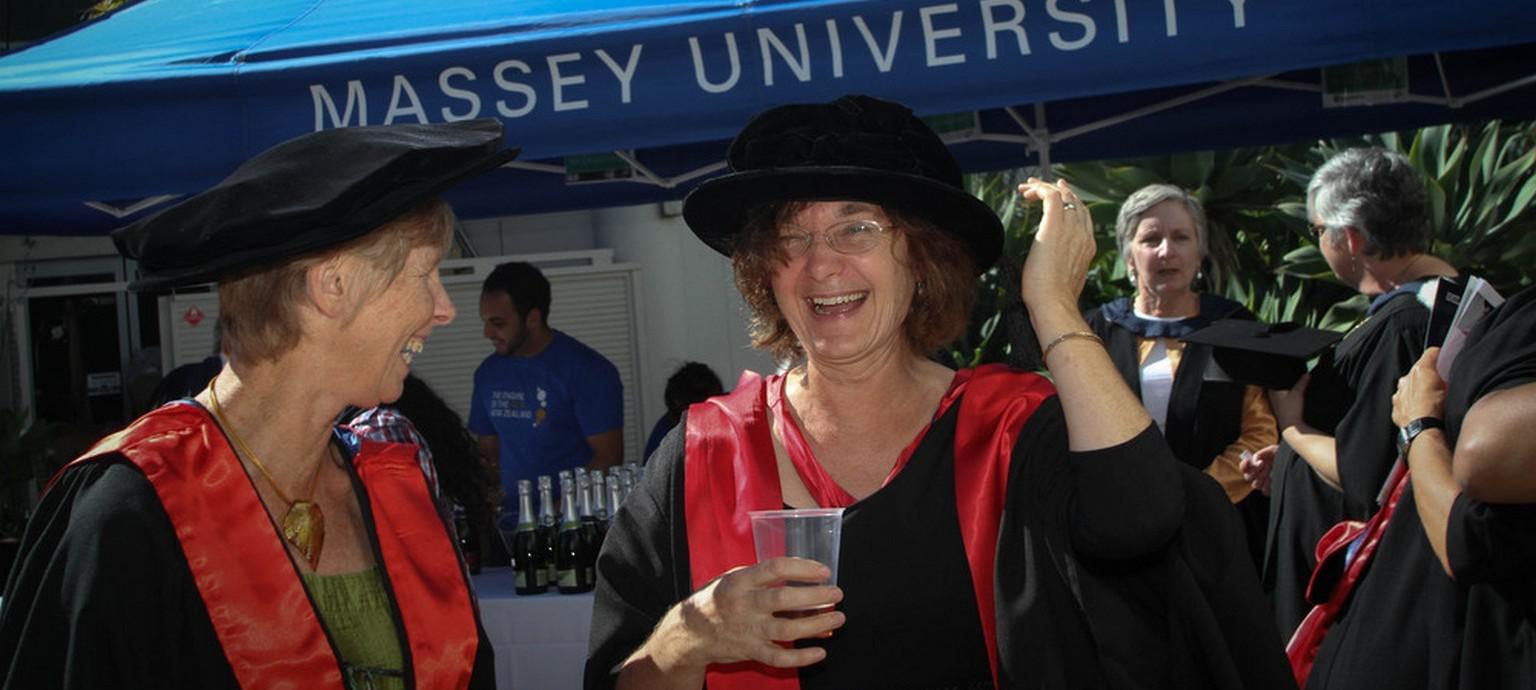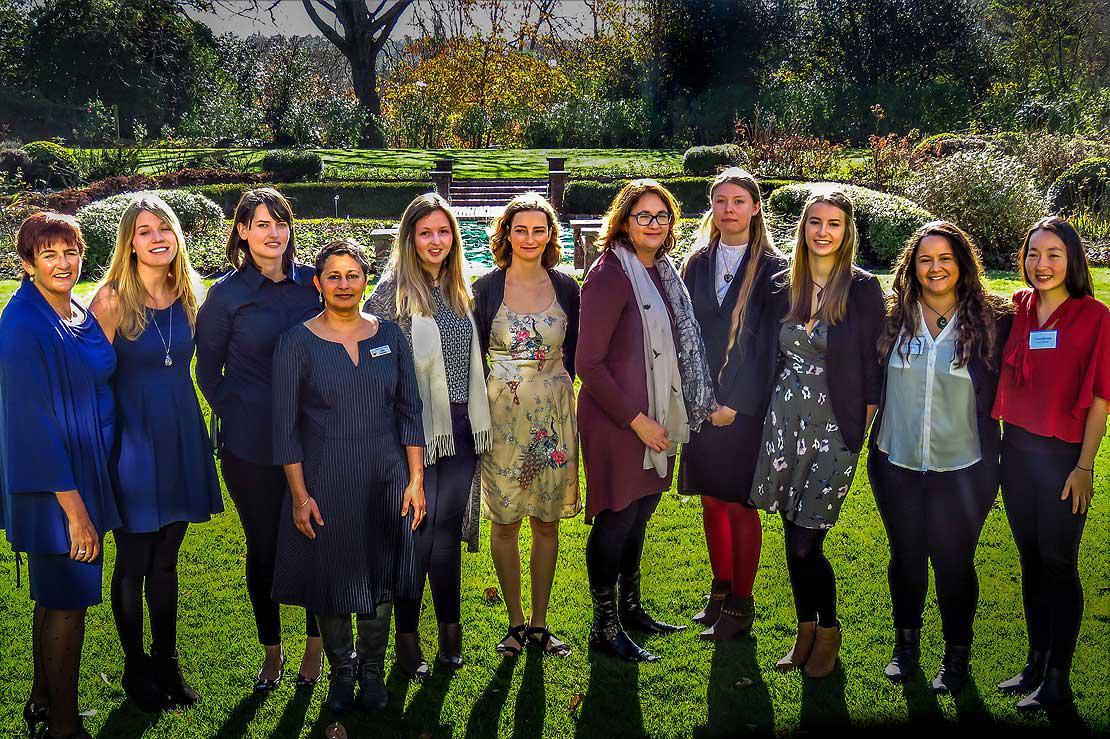The first image is the image on the left, the second image is the image on the right. For the images displayed, is the sentence "Several people stand in a single line outside in the grass in the image on the right." factually correct? Answer yes or no. Yes. The first image is the image on the left, the second image is the image on the right. Given the left and right images, does the statement "The right image features graduates in black robes and caps, with blue and yellow balloons in the air." hold true? Answer yes or no. No. 